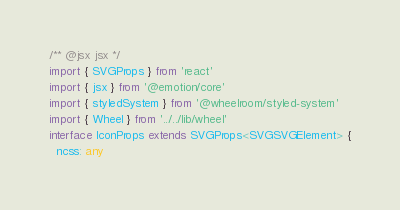<code> <loc_0><loc_0><loc_500><loc_500><_TypeScript_>/** @jsx jsx */
import { SVGProps } from 'react'
import { jsx } from '@emotion/core'
import { styledSystem } from '@wheelroom/styled-system'
import { Wheel } from '../../lib/wheel'
interface IconProps extends SVGProps<SVGSVGElement> {
  ncss: any</code> 